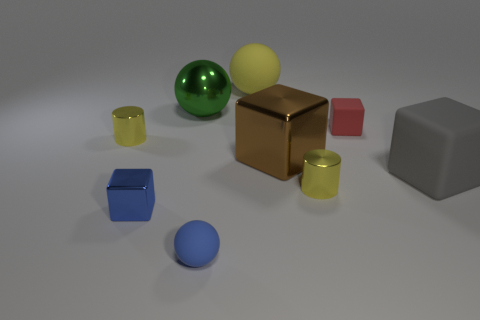There is a gray block that is the same material as the big yellow ball; what is its size?
Give a very brief answer. Large. What number of large yellow things are the same shape as the red rubber object?
Provide a short and direct response. 0. What material is the gray object that is the same size as the metallic ball?
Make the answer very short. Rubber. Is there a tiny cylinder that has the same material as the large green ball?
Give a very brief answer. Yes. There is a small thing that is both behind the gray cube and right of the tiny rubber sphere; what color is it?
Your answer should be very brief. Red. What number of other objects are there of the same color as the small rubber sphere?
Provide a succinct answer. 1. What material is the tiny cube that is right of the tiny block in front of the small red thing that is behind the gray cube made of?
Keep it short and to the point. Rubber. What number of blocks are cyan metallic things or yellow shiny objects?
Provide a short and direct response. 0. How many brown cubes are in front of the tiny yellow cylinder that is behind the yellow metallic thing in front of the large gray block?
Provide a short and direct response. 1. Do the small blue shiny thing and the brown thing have the same shape?
Your answer should be compact. Yes. 